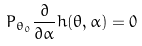<formula> <loc_0><loc_0><loc_500><loc_500>P _ { \theta _ { 0 } } \frac { \partial } { \partial \alpha } h ( \theta , \alpha ) = 0</formula> 